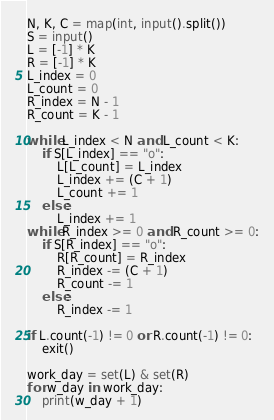Convert code to text. <code><loc_0><loc_0><loc_500><loc_500><_Python_>N, K, C = map(int, input().split())
S = input()
L = [-1] * K
R = [-1] * K
L_index = 0
L_count = 0
R_index = N - 1
R_count = K - 1

while L_index < N and L_count < K:
    if S[L_index] == "o":
        L[L_count] = L_index
        L_index += (C + 1)
        L_count += 1
    else:
        L_index += 1
while R_index >= 0 and R_count >= 0:
    if S[R_index] == "o":
        R[R_count] = R_index
        R_index -= (C + 1)
        R_count -= 1
    else:
        R_index -= 1

if L.count(-1) != 0 or R.count(-1) != 0:
    exit()

work_day = set(L) & set(R)
for w_day in work_day:
    print(w_day + 1)</code> 